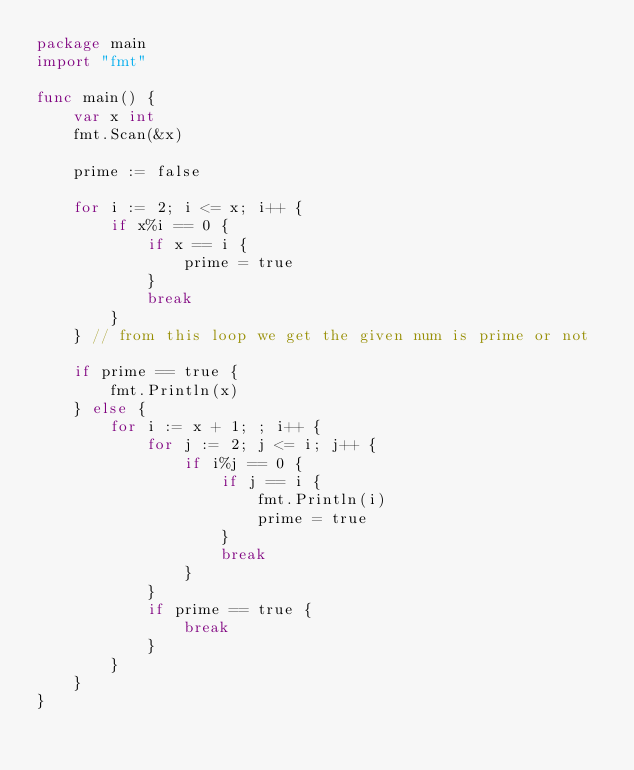<code> <loc_0><loc_0><loc_500><loc_500><_Go_>package main
import "fmt"

func main() {
	var x int
	fmt.Scan(&x)

	prime := false

	for i := 2; i <= x; i++ {
		if x%i == 0 {
			if x == i {
				prime = true
			}
			break
		}
	} // from this loop we get the given num is prime or not

	if prime == true {
		fmt.Println(x)
	} else {
		for i := x + 1; ; i++ {
			for j := 2; j <= i; j++ {
				if i%j == 0 {
					if j == i {
						fmt.Println(i)
						prime = true
					}
					break
				}
			}
			if prime == true {
				break
			}
		}
	}
}</code> 